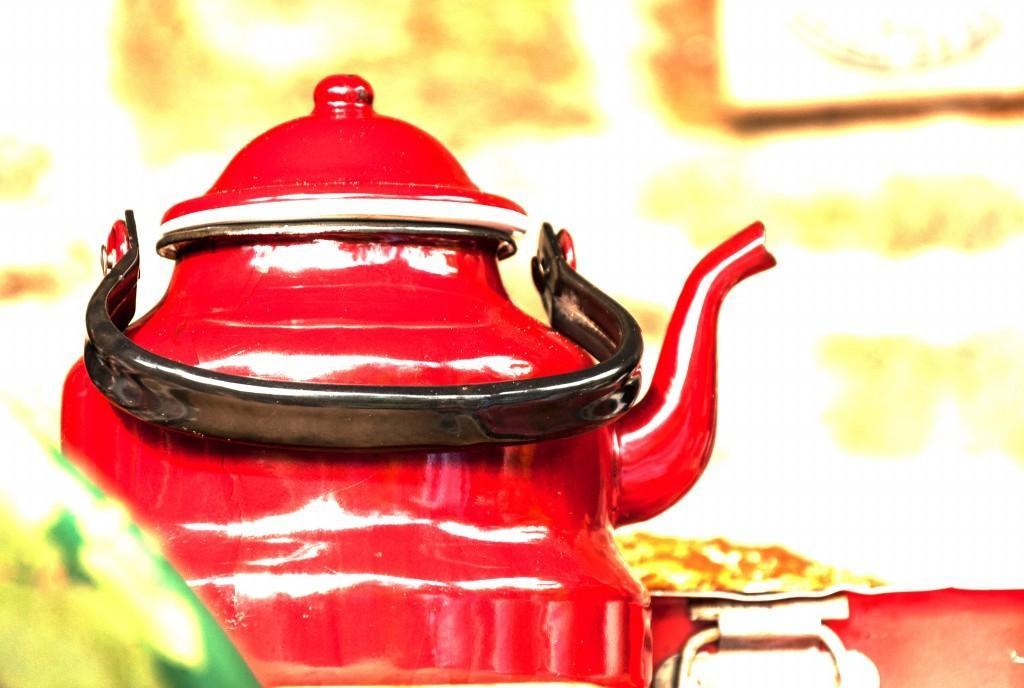Describe this image in one or two sentences. In this image, we can see a tea kettle with lid and handle. In the background, we can see the blur view. Here we can see metal objects. 